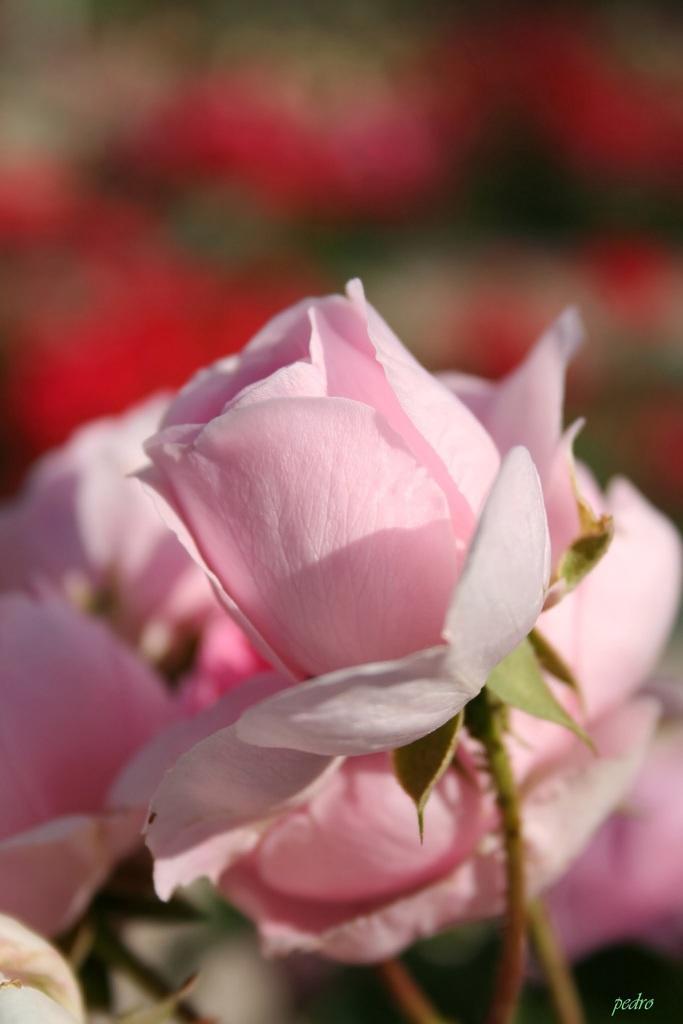Please provide a concise description of this image. There are pink roses. In the background it is blurred. In the right bottom corner there is a watermark. 